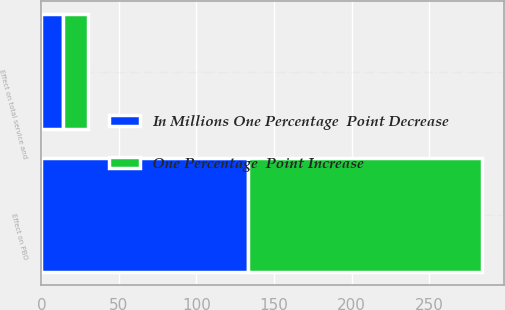<chart> <loc_0><loc_0><loc_500><loc_500><stacked_bar_chart><ecel><fcel>Effect on total service and<fcel>Effect on PBO<nl><fcel>One Percentage  Point Increase<fcel>16<fcel>151<nl><fcel>In Millions One Percentage  Point Decrease<fcel>14<fcel>133<nl></chart> 